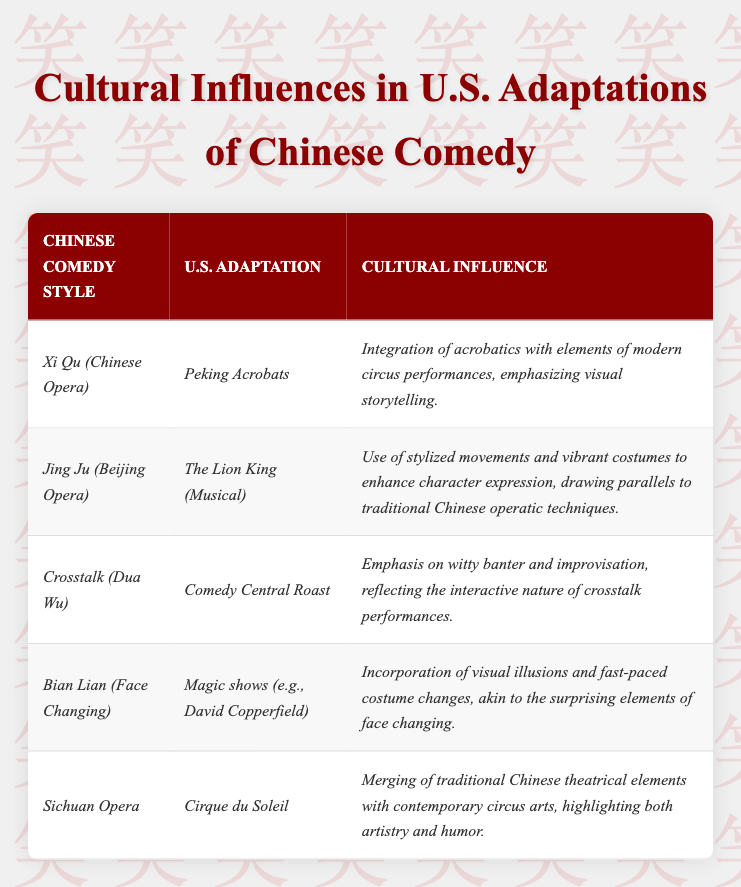What is the U.S. adaptation associated with *Bian Lian (Face Changing)*? The table lists *Magic shows (e.g., David Copperfield)* as the U.S. adaptation for *Bian Lian (Face Changing)*.
Answer: *Magic shows (e.g., David Copperfield)* Which Chinese comedy style is linked to *Comedy Central Roast*? The table indicates that *Crosstalk (Dua Wu)* is the Chinese comedy style associated with *Comedy Central Roast*.
Answer: *Crosstalk (Dua Wu)* What cultural influence is noted for *Cirque du Soleil*? According to the table, *Cirque du Soleil* shows a merging of traditional Chinese theatrical elements with contemporary circus arts, highlighting both artistry and humor.
Answer: *Merging of traditional Chinese theatrical elements...* Which U.S. adaptation emphasizes visual storytelling? The table states that *Peking Acrobats* emphasizes visual storytelling by integrating acrobatics with modern circus performances.
Answer: *Peking Acrobats* How many Chinese comedy styles are presented in the table? The table lists a total of 5 Chinese comedy styles: Xi Qu, Jing Ju, Crosstalk, Bian Lian, and Sichuan Opera. Thus, the count is 5.
Answer: 5 Is *The Lion King (Musical)* an adaptation of *Jing Ju (Beijing Opera)*? Yes, the table confirms that *The Lion King (Musical)* is adapted from *Jing Ju (Beijing Opera)*.
Answer: Yes Which U.S. adaptation involves witty banter and improvisation? The table shows that *Comedy Central Roast* is the U.S. adaptation associated with witty banter and improvisation, reflecting crosstalk performances.
Answer: *Comedy Central Roast* Among the adaptations listed, which one incorporates visual illusions and costume changes? The table mentions that *Magic shows (e.g., David Copperfield)* incorporates visual illusions and fast-paced costume changes, similar to face changing.
Answer: *Magic shows (e.g., David Copperfield)* Which adaptation utilizes stylized movements and vibrant costumes? The table notes that *The Lion King (Musical)* uses stylized movements and vibrant costumes, tying into traditional techniques from Beijing opera.
Answer: *The Lion King (Musical)* What is the common theme observed in both *Sichuan Opera* and *Cirque du Soleil*? Both are noted for merging traditional Chinese theatrical elements with modern circus arts, showcasing a blend of artistry and humor.
Answer: *Merging traditional elements with modern circus arts* 